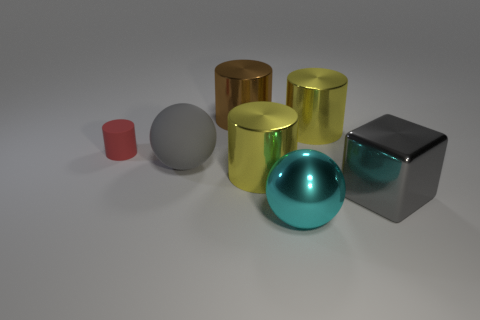Add 1 tiny purple rubber blocks. How many objects exist? 8 Subtract all balls. How many objects are left? 5 Add 4 big cylinders. How many big cylinders exist? 7 Subtract 0 purple cylinders. How many objects are left? 7 Subtract all green shiny cubes. Subtract all red matte objects. How many objects are left? 6 Add 6 rubber objects. How many rubber objects are left? 8 